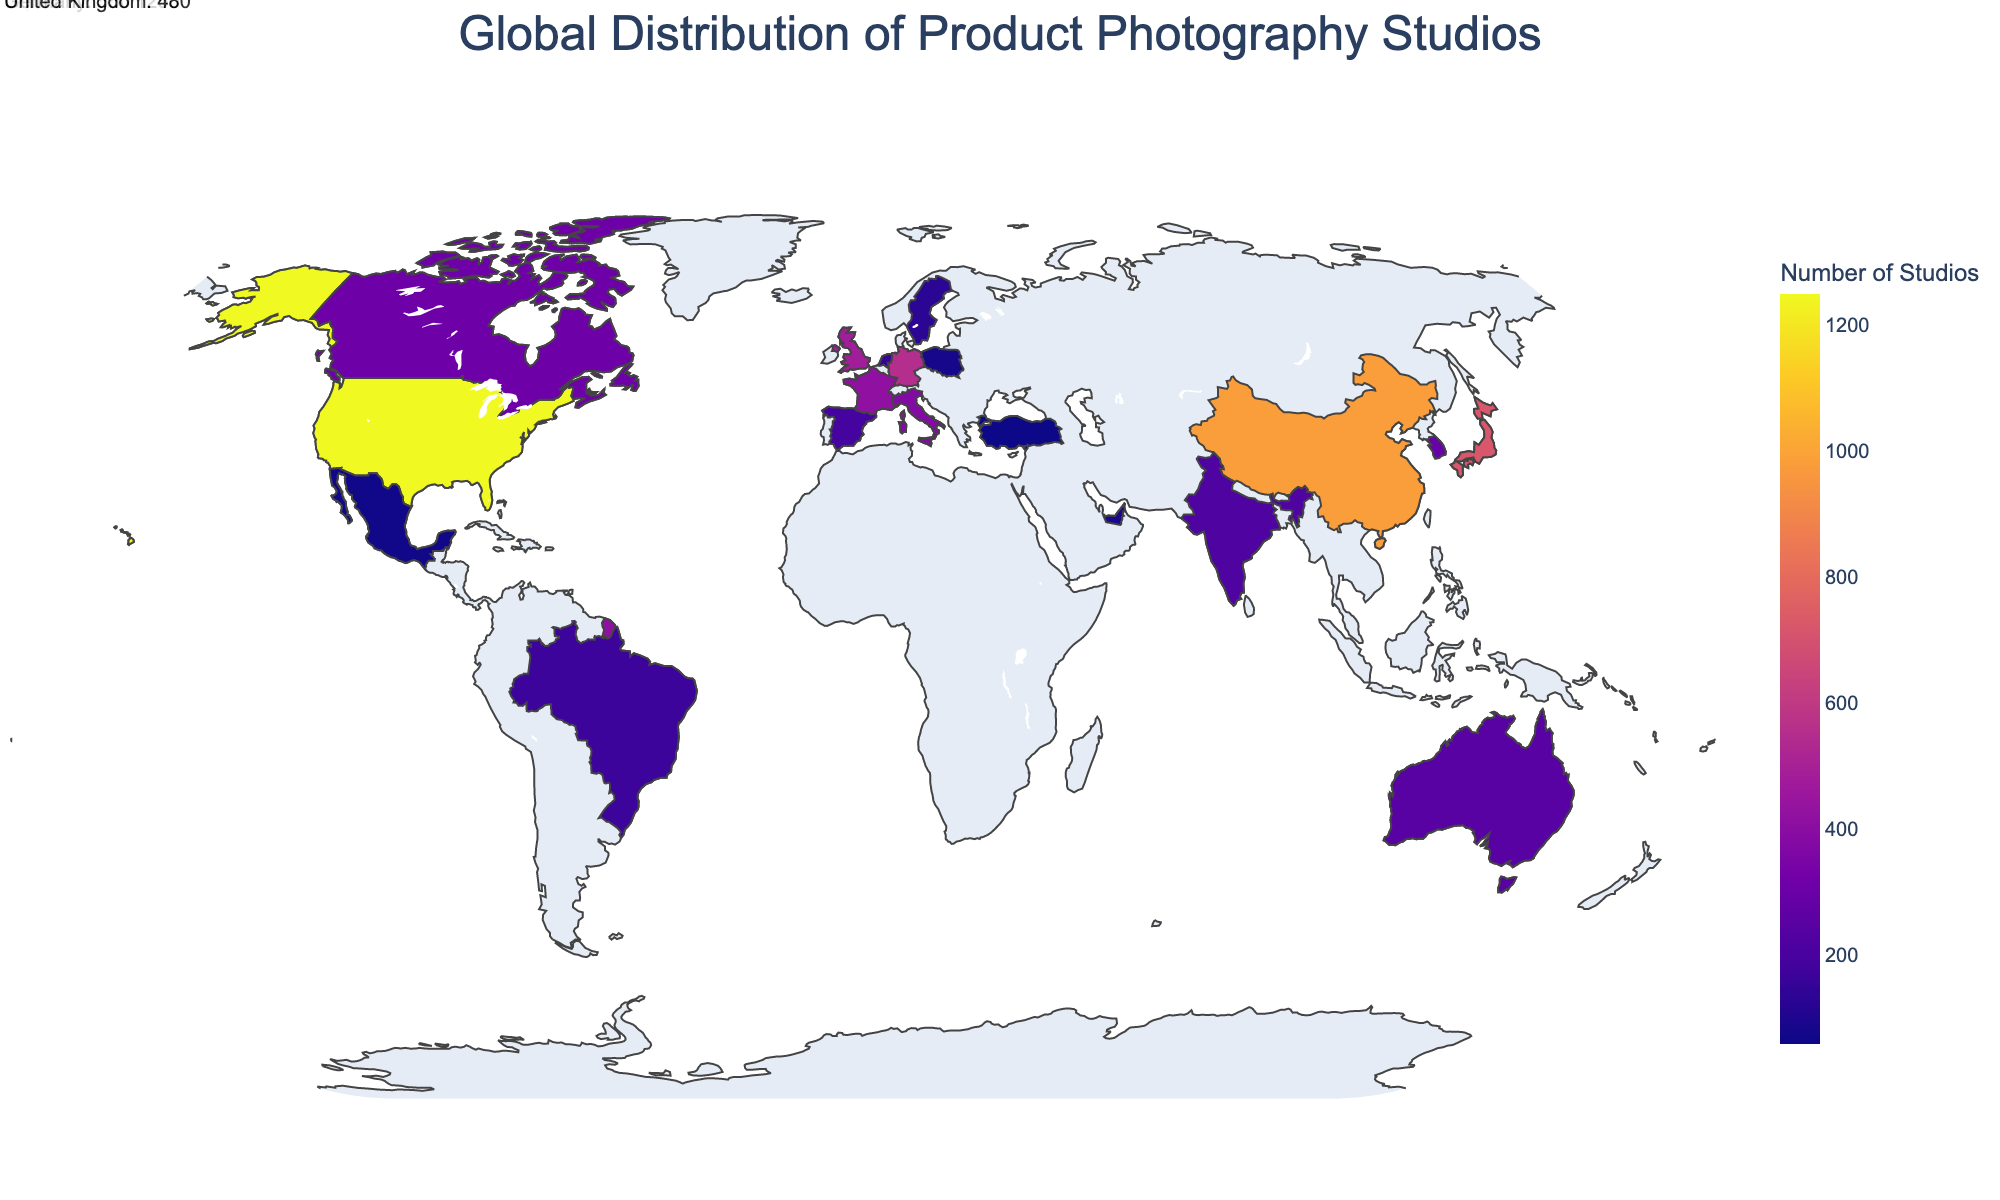Which country has the largest number of product photography studios? By examining the shaded regions on the figure and checking the numerical labels, it is clear that the United States has the highest number of studios with a count of 1250.
Answer: United States What is the total number of product photography studios in the top 3 countries? We need to sum the number of studios in the United States (1250), China (980), and Japan (720). So, 1250 + 980 + 720 = 2950.
Answer: 2950 How does the number of studios in Japan compare to that in Germany? The number of studios in Japan is 720 and in Germany is 550. Since 720 > 550, Japan has more studios compared to Germany.
Answer: Japan has more Which country among the top 5 has the fewest studios, and how many does it have? Looking at the top 5 countries and their corresponding numbers of studios, the United Kingdom is the country with the fewest, at 480.
Answer: United Kingdom, 480 How many countries have fewer than 300 product photography studios? We identify and count which countries have studios less than 300: South Korea, Australia, India, Spain, Brazil, Netherlands, Sweden, Singapore, United Arab Emirates, Poland, Mexico, and Turkey. So there are 12 such countries.
Answer: 12 Is there a country in Europe with more than 500 product photography studios? By examining the data points and considering the countries that are part of Europe, only Germany has more than 500 studios, with a count of 550.
Answer: Yes, Germany Which continent is represented by the country with the second highest number of studios, and what is the number? The country with the second-highest number of studios is China, which is part of Asia, and it has 980 studios.
Answer: Asia, 980 What is the difference in the number of studios between Canada and Australia? Canada has 310 studios, and Australia has 250. The difference is calculated as 310 - 250 = 60.
Answer: 60 On which continent do we see the fewest number of countries with reported photography studios, based on the data? Examining the list, South America has only one country (Brazil) with reported studios.
Answer: South America 